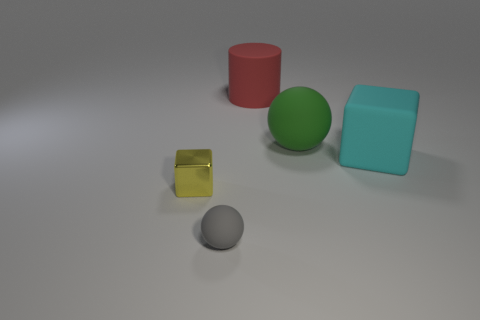What can you tell about the sizes of the various objects in relation to each other? The green sphere and the cyan cube are the largest objects, with the cube having the largest visible surface area. Meanwhile, the red cylinder and the small yellow cube are smaller, and the grey sphere is the smallest object in the scene. These size differences can be inferred by comparing the objects' dimensions and the shadows they cast on the ground, which gives a sense of their scale in relation to one another. 